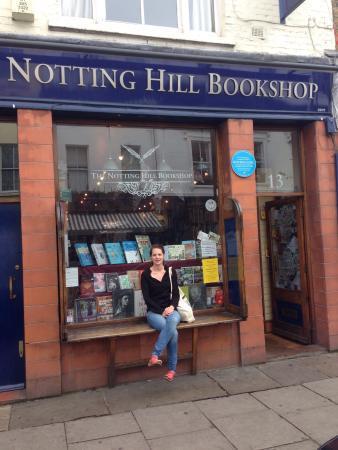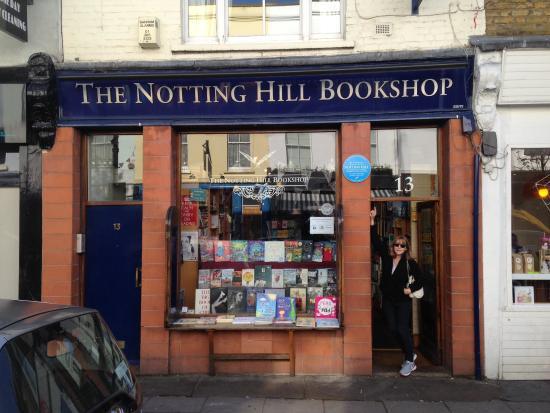The first image is the image on the left, the second image is the image on the right. Given the left and right images, does the statement "Two images of the same brick bookshop with blue trim show a large window between two doorways, a person sitting on a window ledge in one image." hold true? Answer yes or no. Yes. The first image is the image on the left, the second image is the image on the right. Analyze the images presented: Is the assertion "There is a person sitting down on the ledge along the storefront window." valid? Answer yes or no. Yes. 